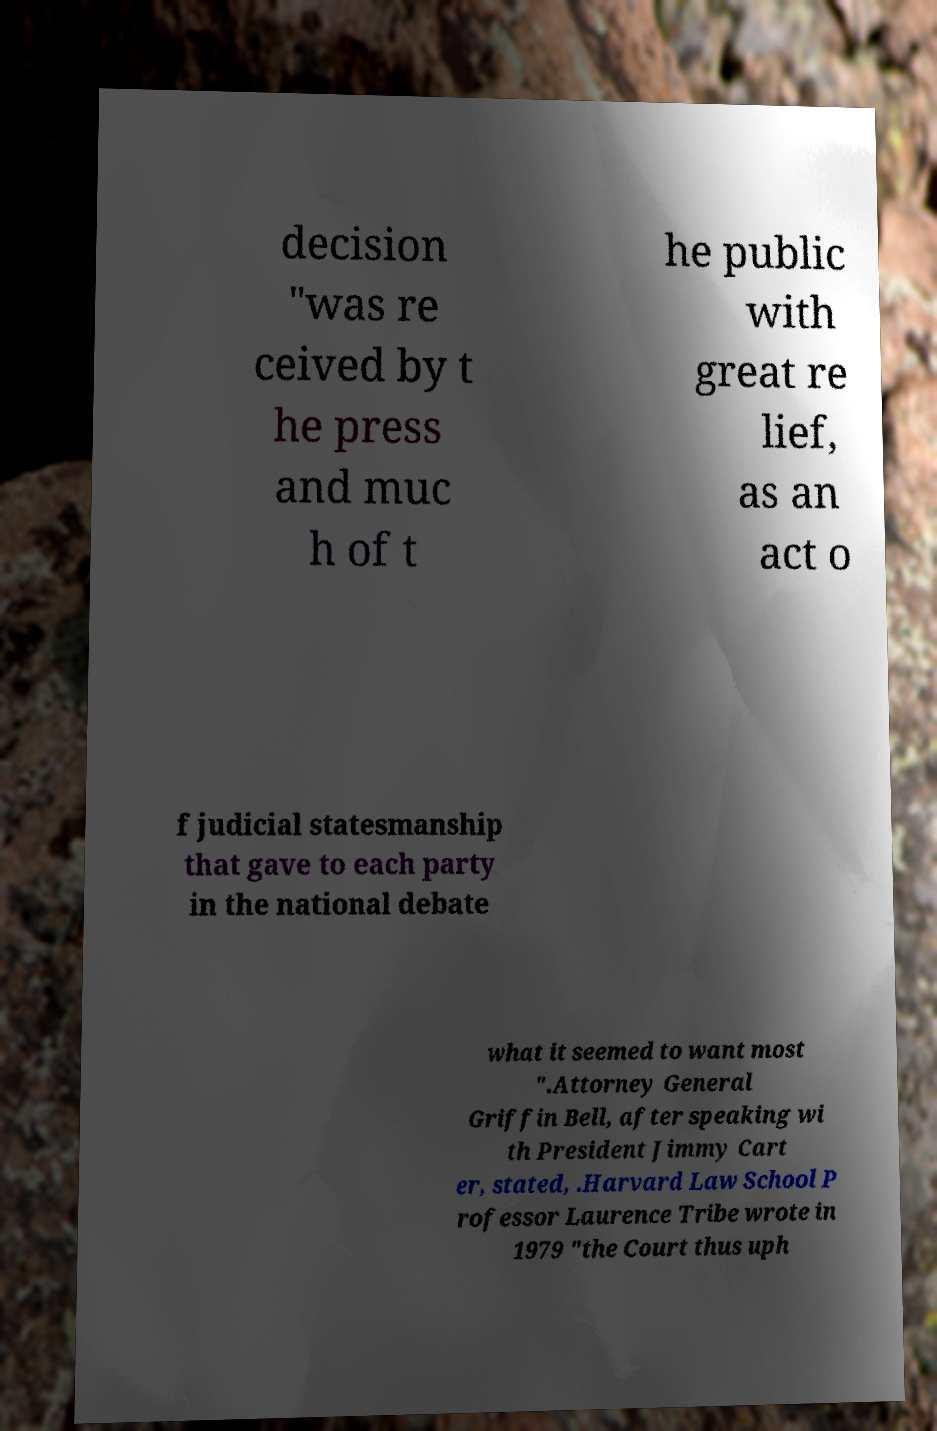What messages or text are displayed in this image? I need them in a readable, typed format. decision "was re ceived by t he press and muc h of t he public with great re lief, as an act o f judicial statesmanship that gave to each party in the national debate what it seemed to want most ".Attorney General Griffin Bell, after speaking wi th President Jimmy Cart er, stated, .Harvard Law School P rofessor Laurence Tribe wrote in 1979 "the Court thus uph 